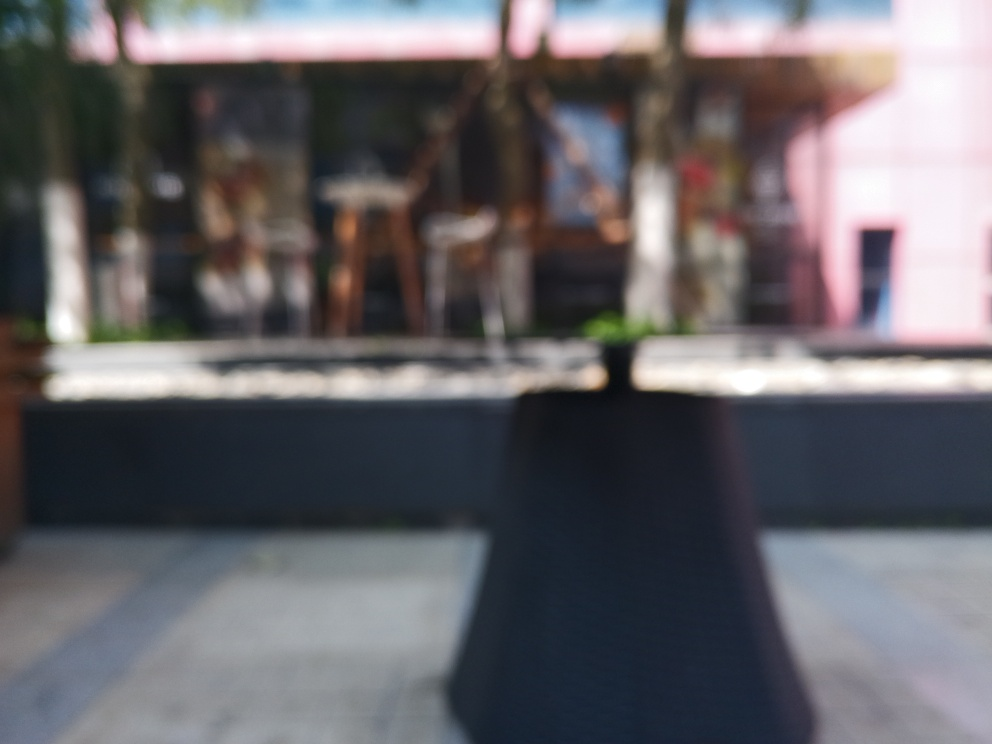If this is an outdoor dining area, what kind of ambiance do you think it's aiming to provide? Judging by the blurred shapes and muted colors, the ambiance seems to be relaxed and casual. The potential presence of plant life suggests a touch of nature, which can create a calm and inviting atmosphere for guests. It's a setting that might encourage people to unwind and enjoy a leisurely experience. 